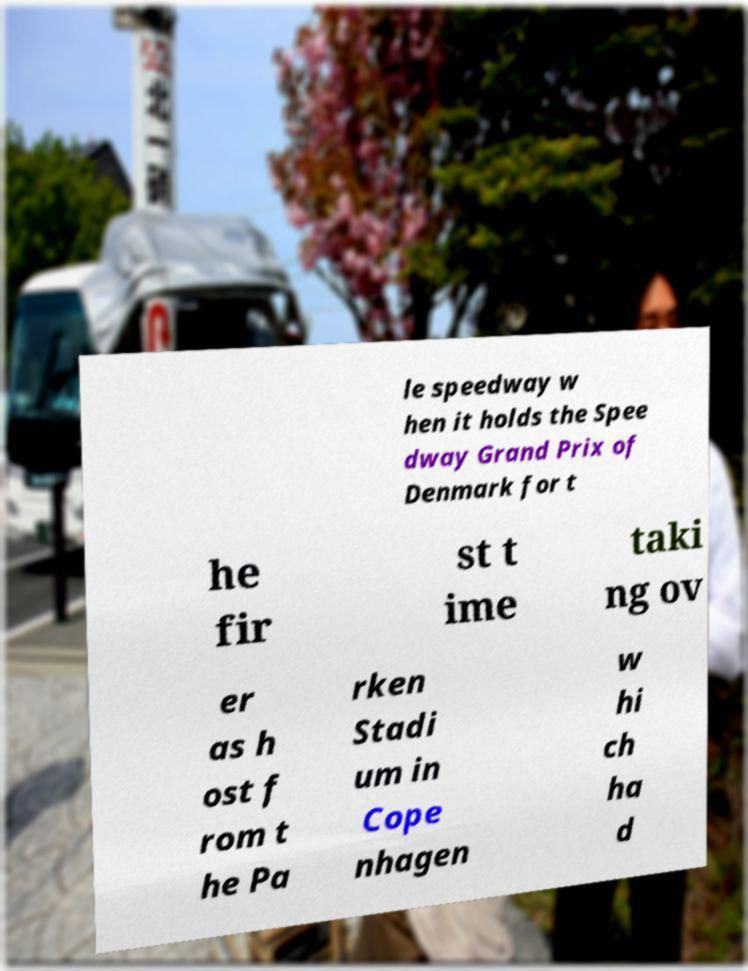Can you accurately transcribe the text from the provided image for me? le speedway w hen it holds the Spee dway Grand Prix of Denmark for t he fir st t ime taki ng ov er as h ost f rom t he Pa rken Stadi um in Cope nhagen w hi ch ha d 